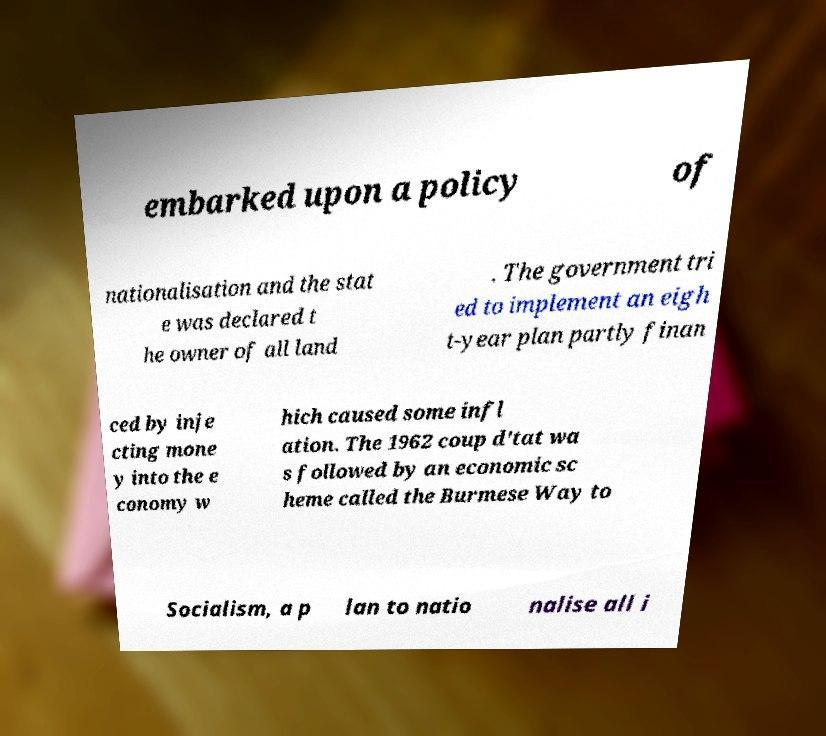What messages or text are displayed in this image? I need them in a readable, typed format. embarked upon a policy of nationalisation and the stat e was declared t he owner of all land . The government tri ed to implement an eigh t-year plan partly finan ced by inje cting mone y into the e conomy w hich caused some infl ation. The 1962 coup d'tat wa s followed by an economic sc heme called the Burmese Way to Socialism, a p lan to natio nalise all i 